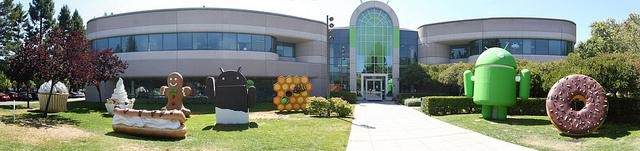What company's mascot can be seen on the right next to the donut? android 